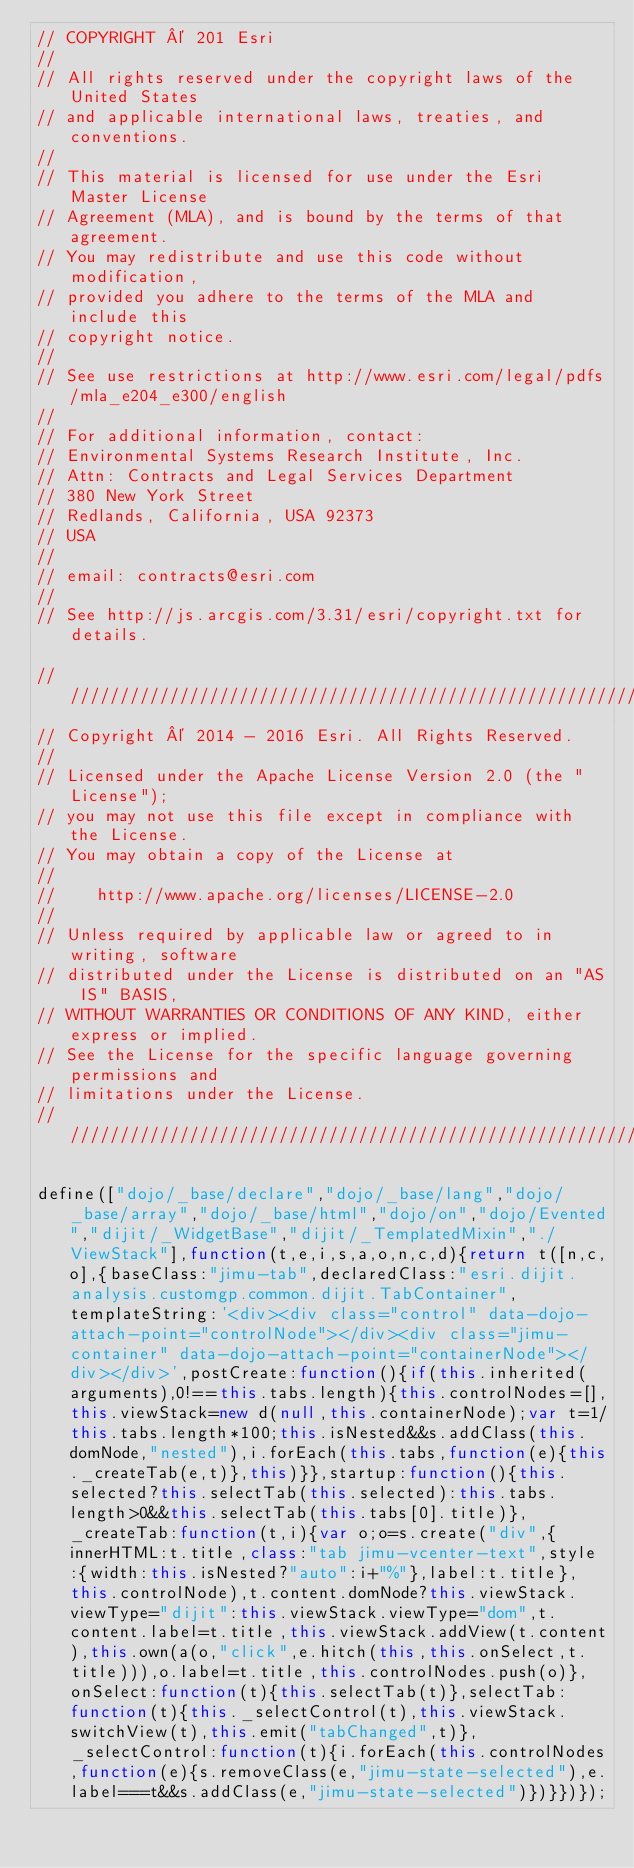<code> <loc_0><loc_0><loc_500><loc_500><_JavaScript_>// COPYRIGHT © 201 Esri
//
// All rights reserved under the copyright laws of the United States
// and applicable international laws, treaties, and conventions.
//
// This material is licensed for use under the Esri Master License
// Agreement (MLA), and is bound by the terms of that agreement.
// You may redistribute and use this code without modification,
// provided you adhere to the terms of the MLA and include this
// copyright notice.
//
// See use restrictions at http://www.esri.com/legal/pdfs/mla_e204_e300/english
//
// For additional information, contact:
// Environmental Systems Research Institute, Inc.
// Attn: Contracts and Legal Services Department
// 380 New York Street
// Redlands, California, USA 92373
// USA
//
// email: contracts@esri.com
//
// See http://js.arcgis.com/3.31/esri/copyright.txt for details.

///////////////////////////////////////////////////////////////////////////
// Copyright © 2014 - 2016 Esri. All Rights Reserved.
//
// Licensed under the Apache License Version 2.0 (the "License");
// you may not use this file except in compliance with the License.
// You may obtain a copy of the License at
//
//    http://www.apache.org/licenses/LICENSE-2.0
//
// Unless required by applicable law or agreed to in writing, software
// distributed under the License is distributed on an "AS IS" BASIS,
// WITHOUT WARRANTIES OR CONDITIONS OF ANY KIND, either express or implied.
// See the License for the specific language governing permissions and
// limitations under the License.
///////////////////////////////////////////////////////////////////////////

define(["dojo/_base/declare","dojo/_base/lang","dojo/_base/array","dojo/_base/html","dojo/on","dojo/Evented","dijit/_WidgetBase","dijit/_TemplatedMixin","./ViewStack"],function(t,e,i,s,a,o,n,c,d){return t([n,c,o],{baseClass:"jimu-tab",declaredClass:"esri.dijit.analysis.customgp.common.dijit.TabContainer",templateString:'<div><div class="control" data-dojo-attach-point="controlNode"></div><div class="jimu-container" data-dojo-attach-point="containerNode"></div></div>',postCreate:function(){if(this.inherited(arguments),0!==this.tabs.length){this.controlNodes=[],this.viewStack=new d(null,this.containerNode);var t=1/this.tabs.length*100;this.isNested&&s.addClass(this.domNode,"nested"),i.forEach(this.tabs,function(e){this._createTab(e,t)},this)}},startup:function(){this.selected?this.selectTab(this.selected):this.tabs.length>0&&this.selectTab(this.tabs[0].title)},_createTab:function(t,i){var o;o=s.create("div",{innerHTML:t.title,class:"tab jimu-vcenter-text",style:{width:this.isNested?"auto":i+"%"},label:t.title},this.controlNode),t.content.domNode?this.viewStack.viewType="dijit":this.viewStack.viewType="dom",t.content.label=t.title,this.viewStack.addView(t.content),this.own(a(o,"click",e.hitch(this,this.onSelect,t.title))),o.label=t.title,this.controlNodes.push(o)},onSelect:function(t){this.selectTab(t)},selectTab:function(t){this._selectControl(t),this.viewStack.switchView(t),this.emit("tabChanged",t)},_selectControl:function(t){i.forEach(this.controlNodes,function(e){s.removeClass(e,"jimu-state-selected"),e.label===t&&s.addClass(e,"jimu-state-selected")})}})});</code> 